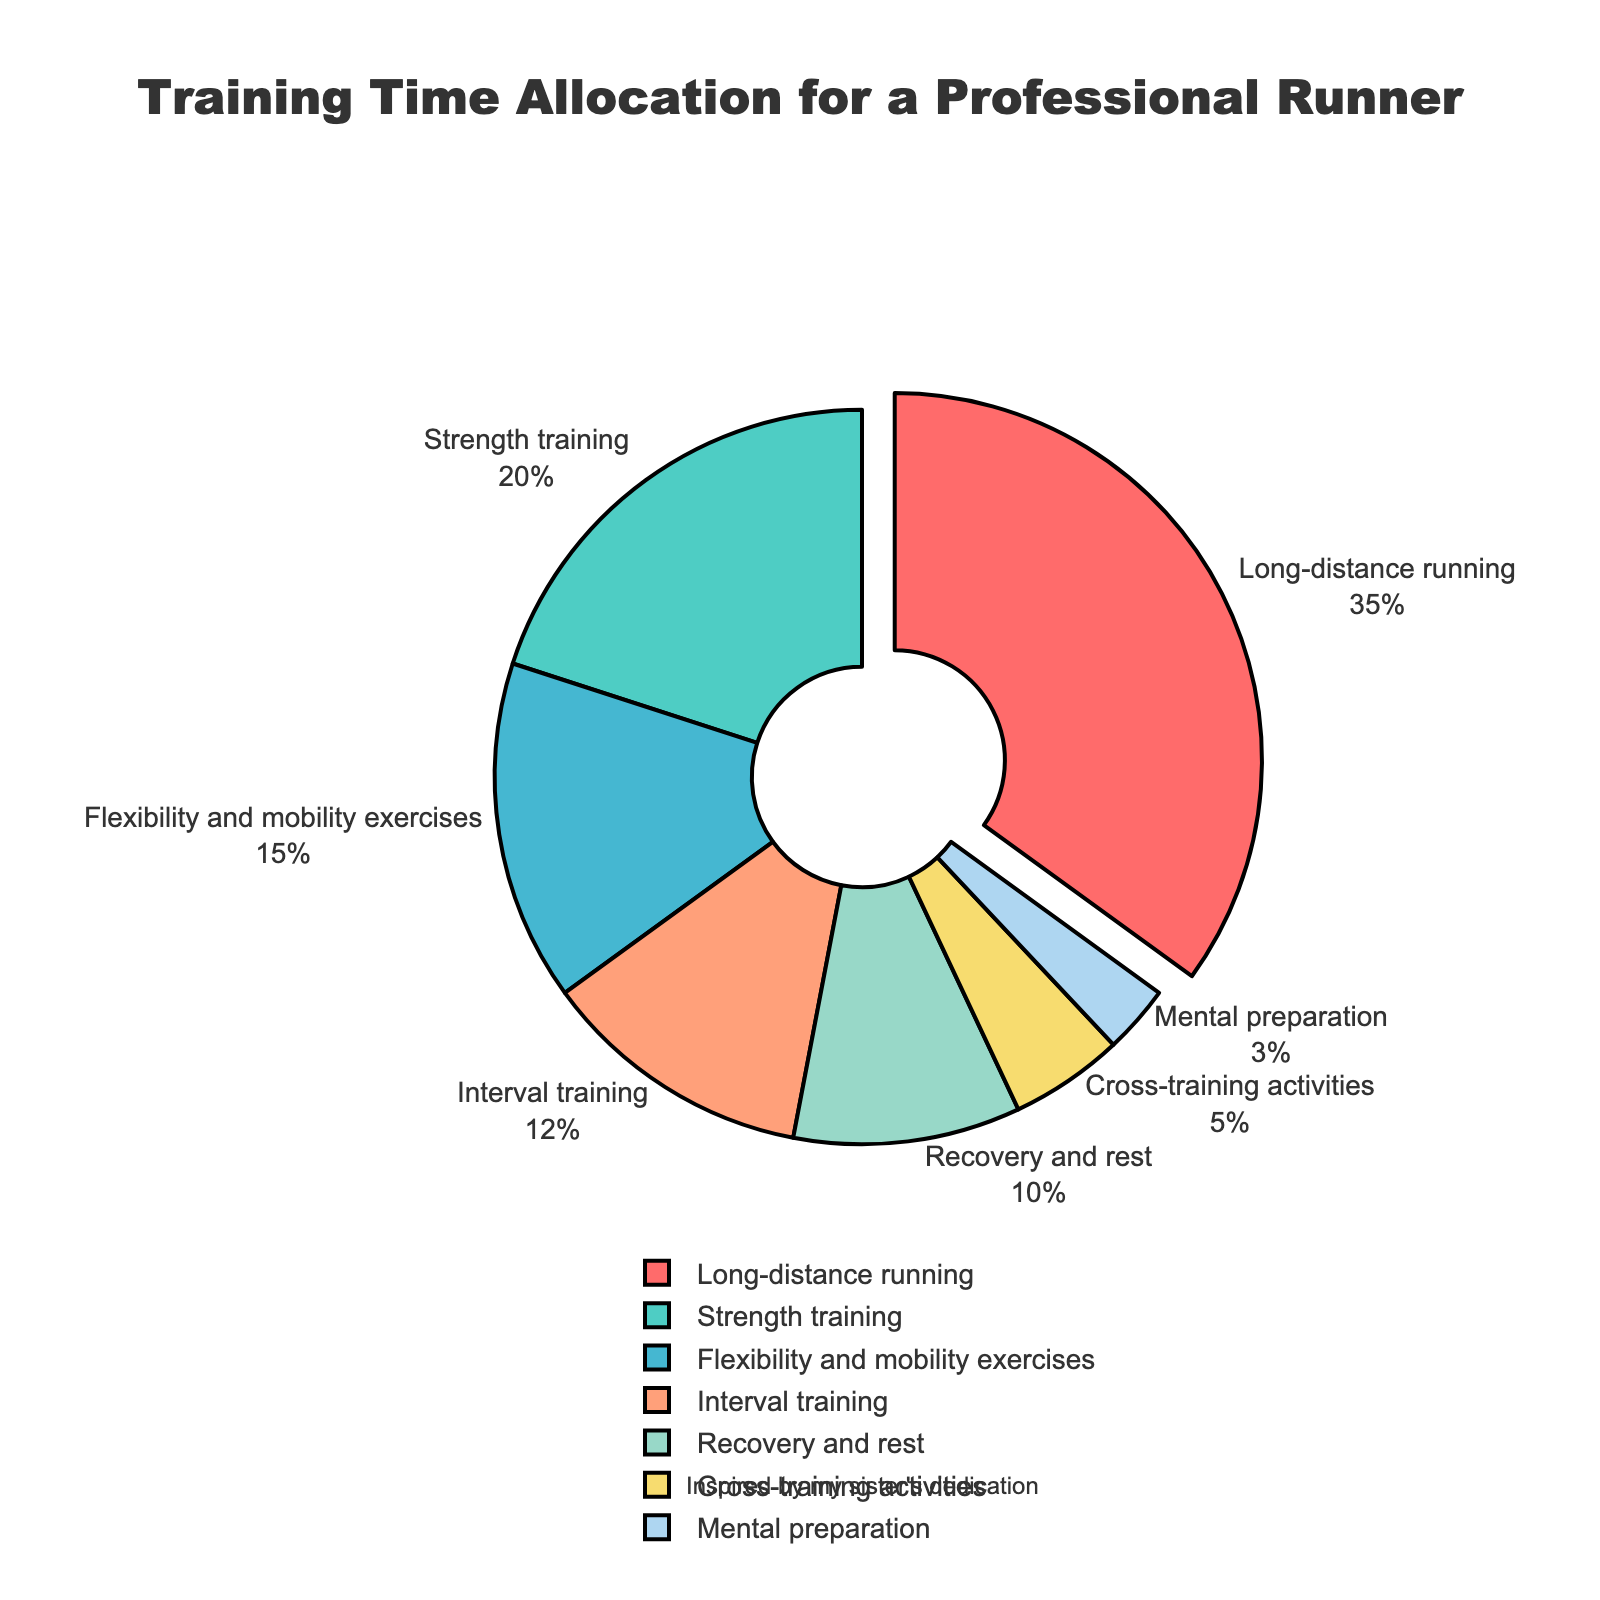What category takes up the largest portion of the training time? The largest segment in the pie chart is visually the segment pulled out from the rest. Checking the label next to this segment and its percentage shows "Long-distance running" with 35%.
Answer: Long-distance running Which two categories combined take up the majority of the training time? Adding the percentages for Long-distance running and Strength training, the two largest segments, gives 35% + 20% = 55%, which is more than half of the total.
Answer: Long-distance running and Strength training How much more time is allocated to Flexibility and mobility exercises compared to Mental preparation? Subtracting the percentage for Mental preparation from Flexibility and mobility exercises, we get 15% - 3% = 12%.
Answer: 12% Are Recovery and rest allocated more time than Cross-training activities? Yes, the segment for Recovery and rest (10%) is visually larger than Cross-training activities (5%).
Answer: Yes What percentage of the time is not spent on running-related activities (assuming Long-distance running and Interval training are running-related)? Adding the percentages for all other categories except Long-distance running and Interval training, we get 20% + 15% + 10% + 5% + 3% = 53%.
Answer: 53% If the runner decides to spend 10% more time on Strength training, what will be the new percentage for Strength training and the total running-related activities? Increase Strength training by 10%: 20% + 10% = 30%. The new total percentage spent on running-related activities (Long-distance running and Interval training) is unchanged: 35% + 12% = 47%.
Answer: 30% and 47% Which category is allocated the least amount of time, and what is its percentage? Looking at the segments and their labels, the smallest is Mental preparation with 3%.
Answer: Mental preparation, 3% How many categories have an allocation of at least 10% of the training time? Counting the segments with labels indicating 10% or more (Long-distance running, Strength training, Flexibility and mobility exercises, Recovery and rest), there are 4 categories.
Answer: 4 By what percentage does Long-distance running exceed Interval training? Subtract the percentage for Interval training from Long-distance running: 35% - 12% = 23%.
Answer: 23% If the allocation for Cross-training activities is doubled, what will be its new percentage and how will that affect the total percentage of non-running activities? Doubling Cross-training activities: 5% * 2 = 10%. The new total for non-running activities: 30% (previous non-running activities) - 5% (original Cross-training) + 10% (new Cross-training) = 55%.
Answer: 10% and 55% 